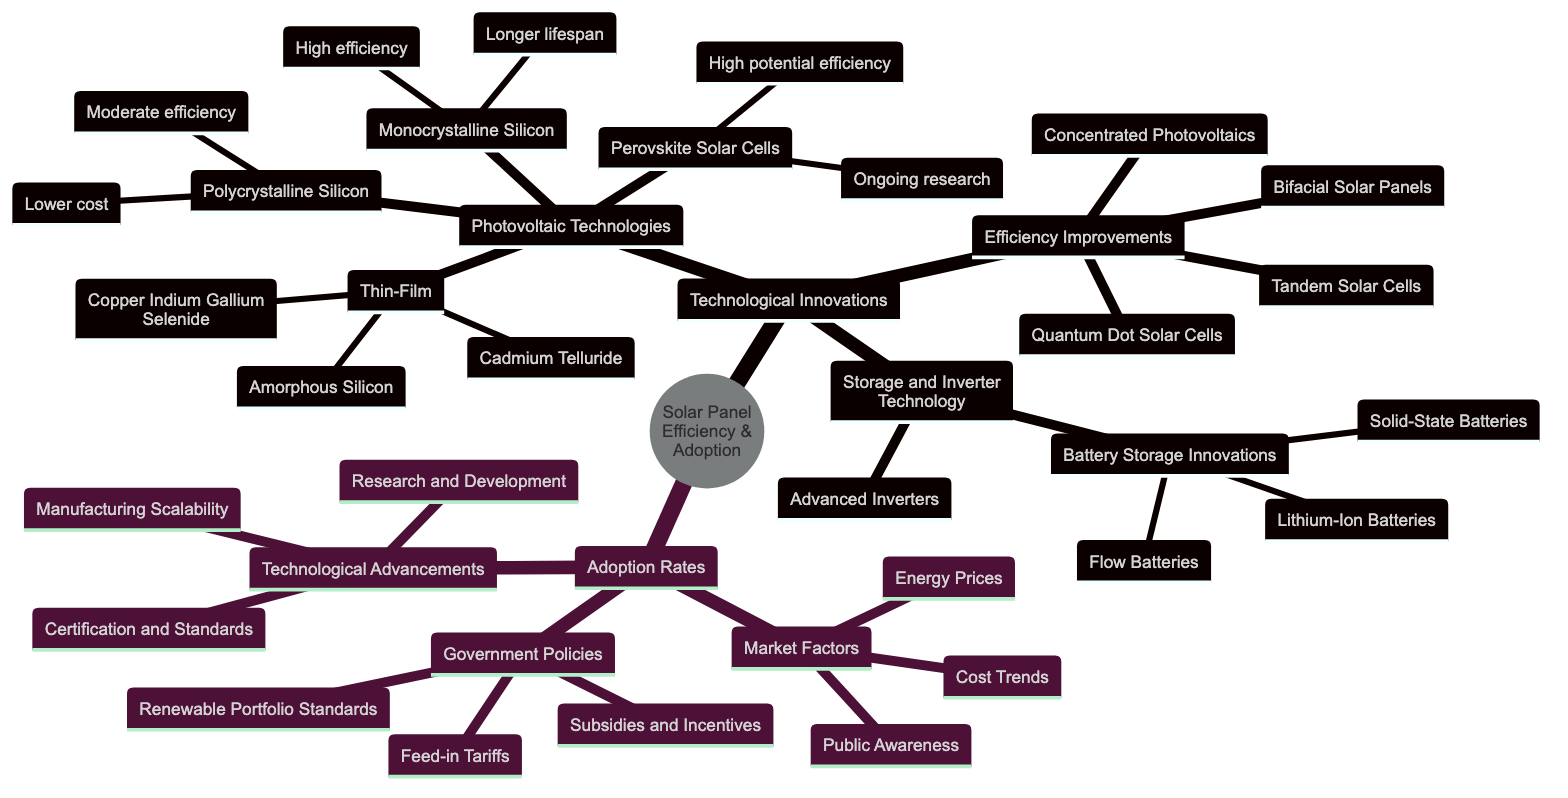What are the three types of Photovoltaic Technologies listed? The diagram lists Monocrystalline Silicon, Polycrystalline Silicon, and Thin-Film as the three types of Photovoltaic Technologies.
Answer: Monocrystalline Silicon, Polycrystalline Silicon, Thin-Film How many innovations are listed under Efficiency Improvements? The diagram shows four innovations under Efficiency Improvements: Bifacial Solar Panels, Tandem Solar Cells, Quantum Dot Solar Cells, and Concentrated Photovoltaics.
Answer: 4 What type of battery storage is described as next-gen with increased safety? The diagram indicates that Solid-State Batteries are described as next-gen with increased safety and higher capacity.
Answer: Solid-State Batteries Which technological advancement involves reducing costs through scalability? The diagram states that Manufacturing Scalability is the advancement that focuses on the ability to produce at large scale, thus reducing costs.
Answer: Manufacturing Scalability What government policy pays for the electricity generated by solar panels? The diagram specifies that Feed-in Tariffs are the government policy that pays for the electricity produced by solar panels.
Answer: Feed-in Tariffs Which photovoltaic technology has a high potential efficiency and is still under research? The diagram indicates that Perovskite Solar Cells have high potential efficiency and are currently in ongoing research.
Answer: Perovskite Solar Cells How does public awareness factor into market adoption of solar technologies? The diagram shows that Public Awareness is a market factor, highlighting the rising concern about climate change that likely influences the adoption of solar technologies.
Answer: Public Awareness What is the primary advantage of Bifacial Solar Panels? The diagram notes that Bifacial Solar Panels have the advantage of being able to capture sunlight from both sides.
Answer: Capture sunlight from both sides What does advanced inverters improve in solar technology? The diagram states that Advanced Inverters improve energy conversion efficiency in solar technology.
Answer: Energy conversion efficiency 